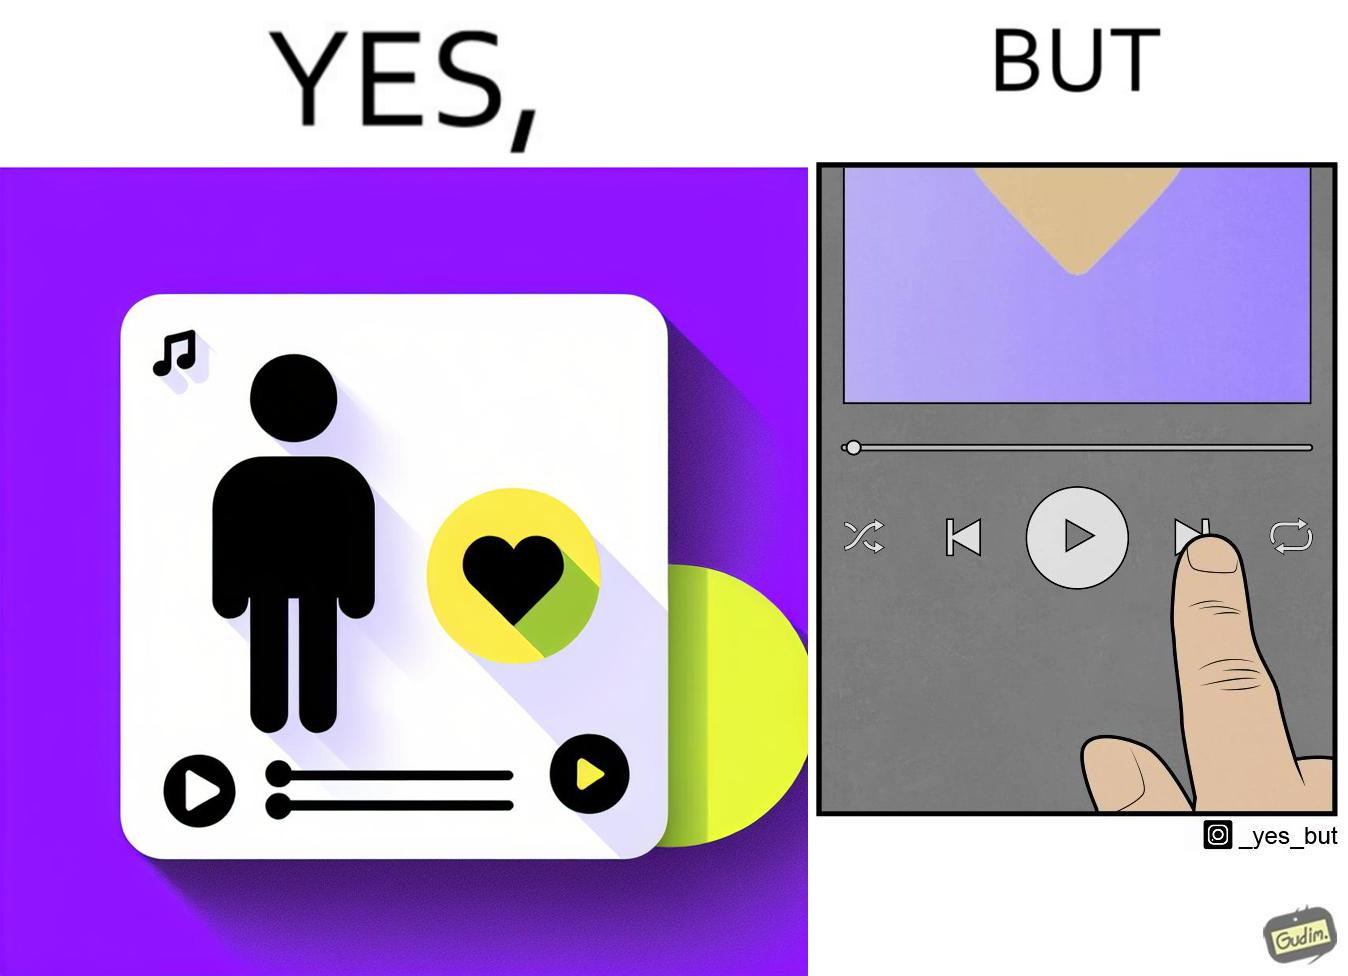Describe what you see in the left and right parts of this image. In the left part of the image: The image shows a playlist named "music I love" with a green play button. There is also an icon of yellow heart with purple background. In the right part of the image: The image shows the next button being pressed on a music application with only a few seconds into the current music. 